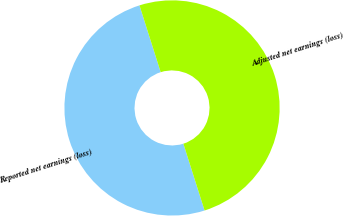Convert chart. <chart><loc_0><loc_0><loc_500><loc_500><pie_chart><fcel>Reported net earnings (loss)<fcel>Adjusted net earnings (loss)<nl><fcel>50.0%<fcel>50.0%<nl></chart> 